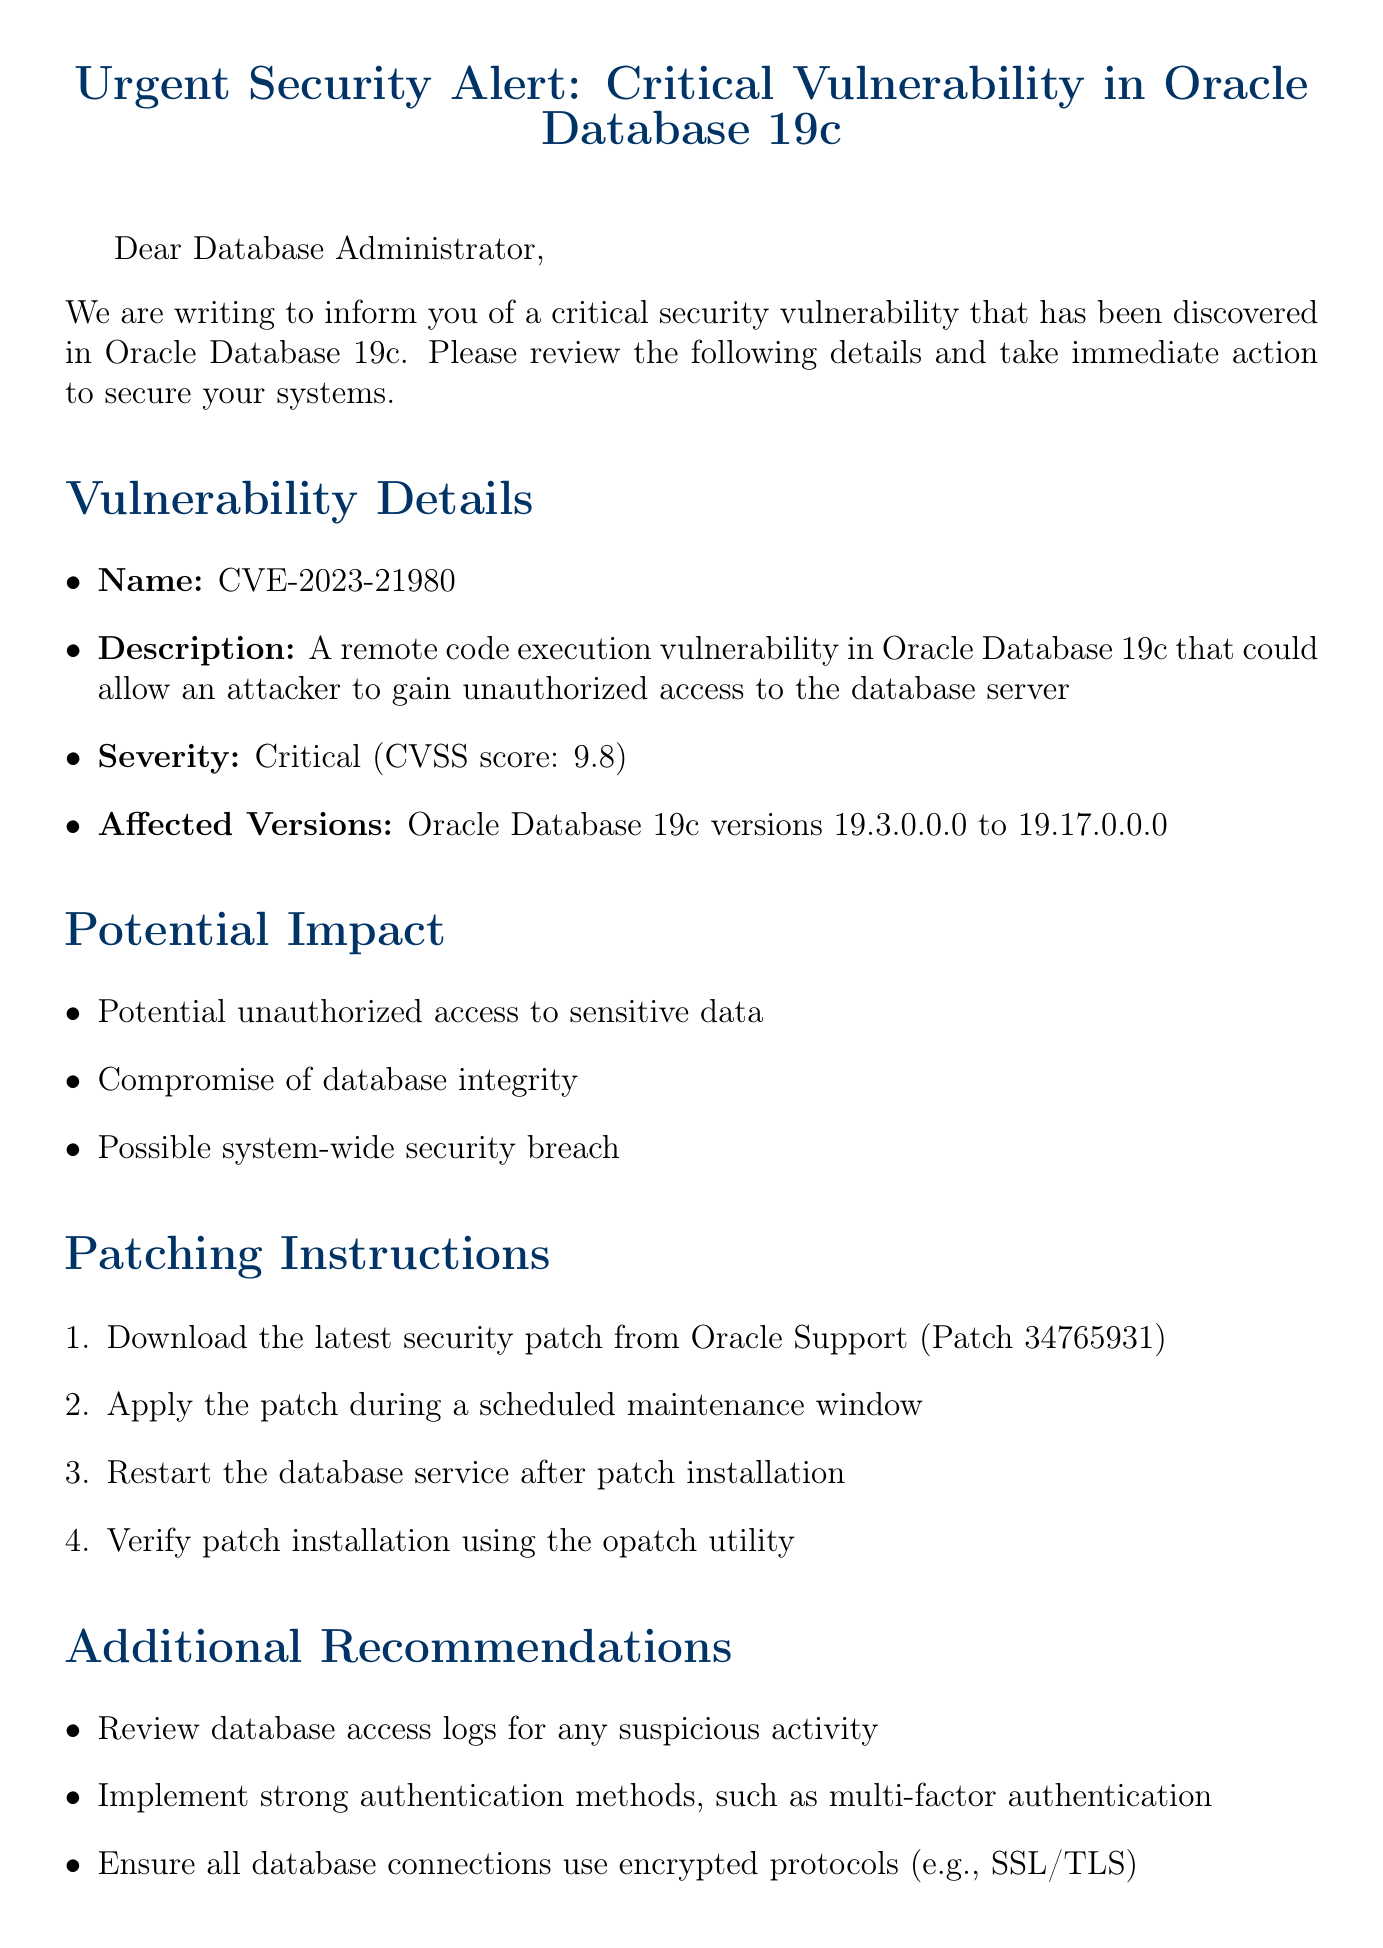What is the vulnerability name? The vulnerability name is mentioned in the document under "Vulnerability Details".
Answer: CVE-2023-21980 What is the CVSS score for this vulnerability? The CVSS score is indicated in the "Severity" section of the document.
Answer: 9.8 Which database version is affected? The affected versions are listed under "Vulnerability Details".
Answer: Oracle Database 19c versions 19.3.0.0.0 to 19.17.0.0.0 What is one potential impact of this vulnerability? One potential impact is listed under "Potential Impact".
Answer: Compromise of database integrity What is the first step in the patching instructions? The first step is outlined in the "Patching Instructions" section of the document.
Answer: Download the latest security patch from Oracle Support (Patch 34765931) How should the database service be handled after patch installation? Instructions about the database service after patch installation are included in "Patching Instructions".
Answer: Restart the database service after patch installation What is one additional recommendation for security? Additional recommendations can be found in the "Additional Recommendations" section.
Answer: Implement strong authentication methods, such as multi-factor authentication Who should be contacted for internal support? The document specifies who to contact under "Resources".
Answer: IT Security team at security@yourcompany.com What is the aim of prioritizing the patching process? The aim is stated in the closing paragraph.
Answer: To maintain the security and integrity of our database systems 